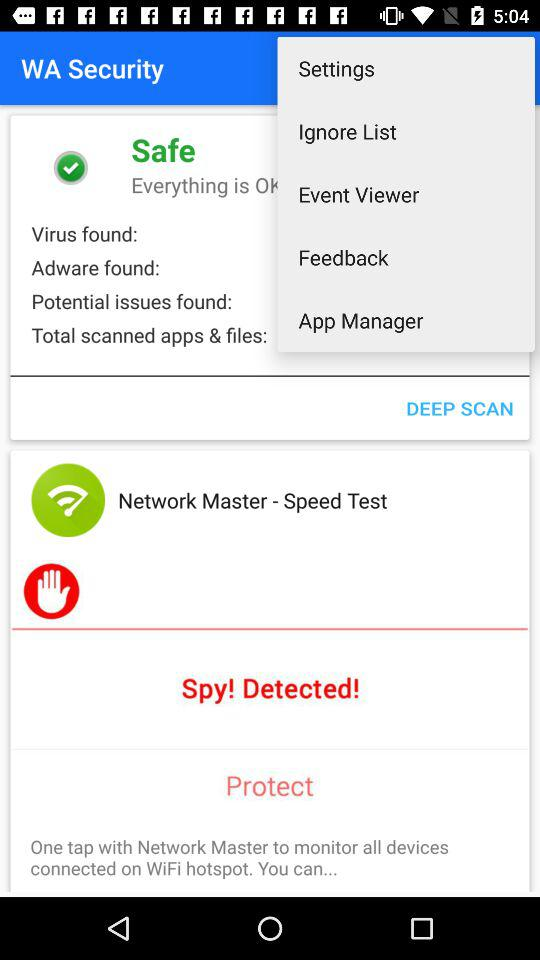How many more adware have been found than potential issues?
Answer the question using a single word or phrase. 0 